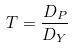Convert formula to latex. <formula><loc_0><loc_0><loc_500><loc_500>T = \frac { D _ { P } } { D _ { Y } }</formula> 